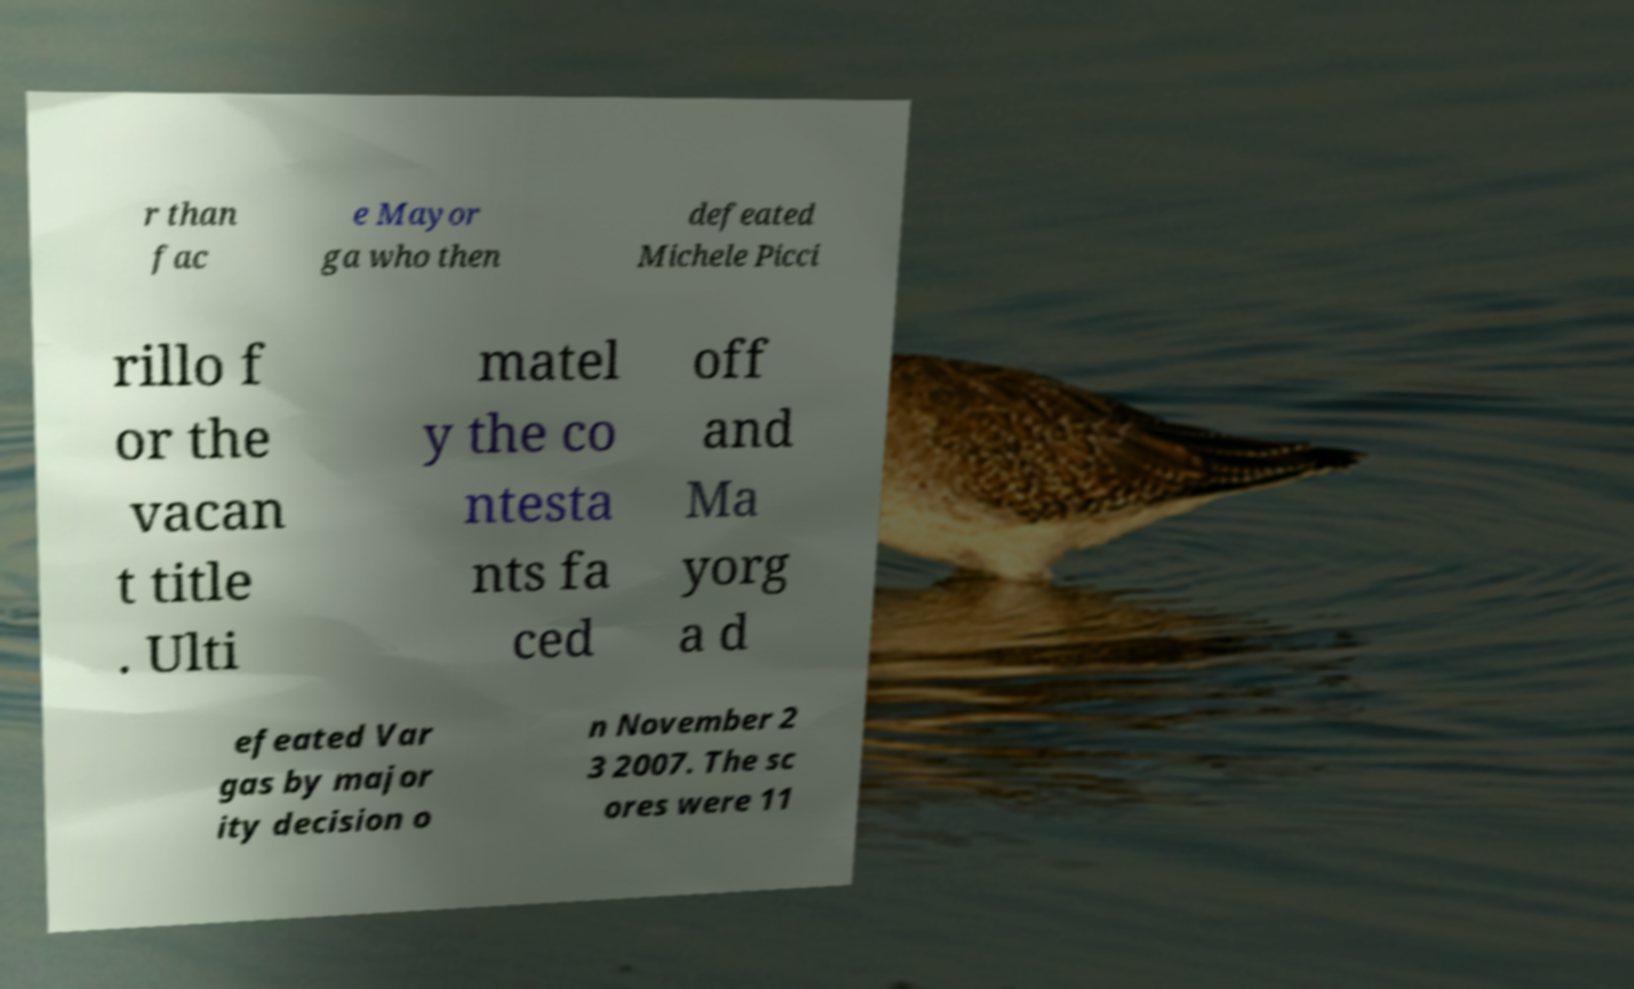Could you extract and type out the text from this image? r than fac e Mayor ga who then defeated Michele Picci rillo f or the vacan t title . Ulti matel y the co ntesta nts fa ced off and Ma yorg a d efeated Var gas by major ity decision o n November 2 3 2007. The sc ores were 11 